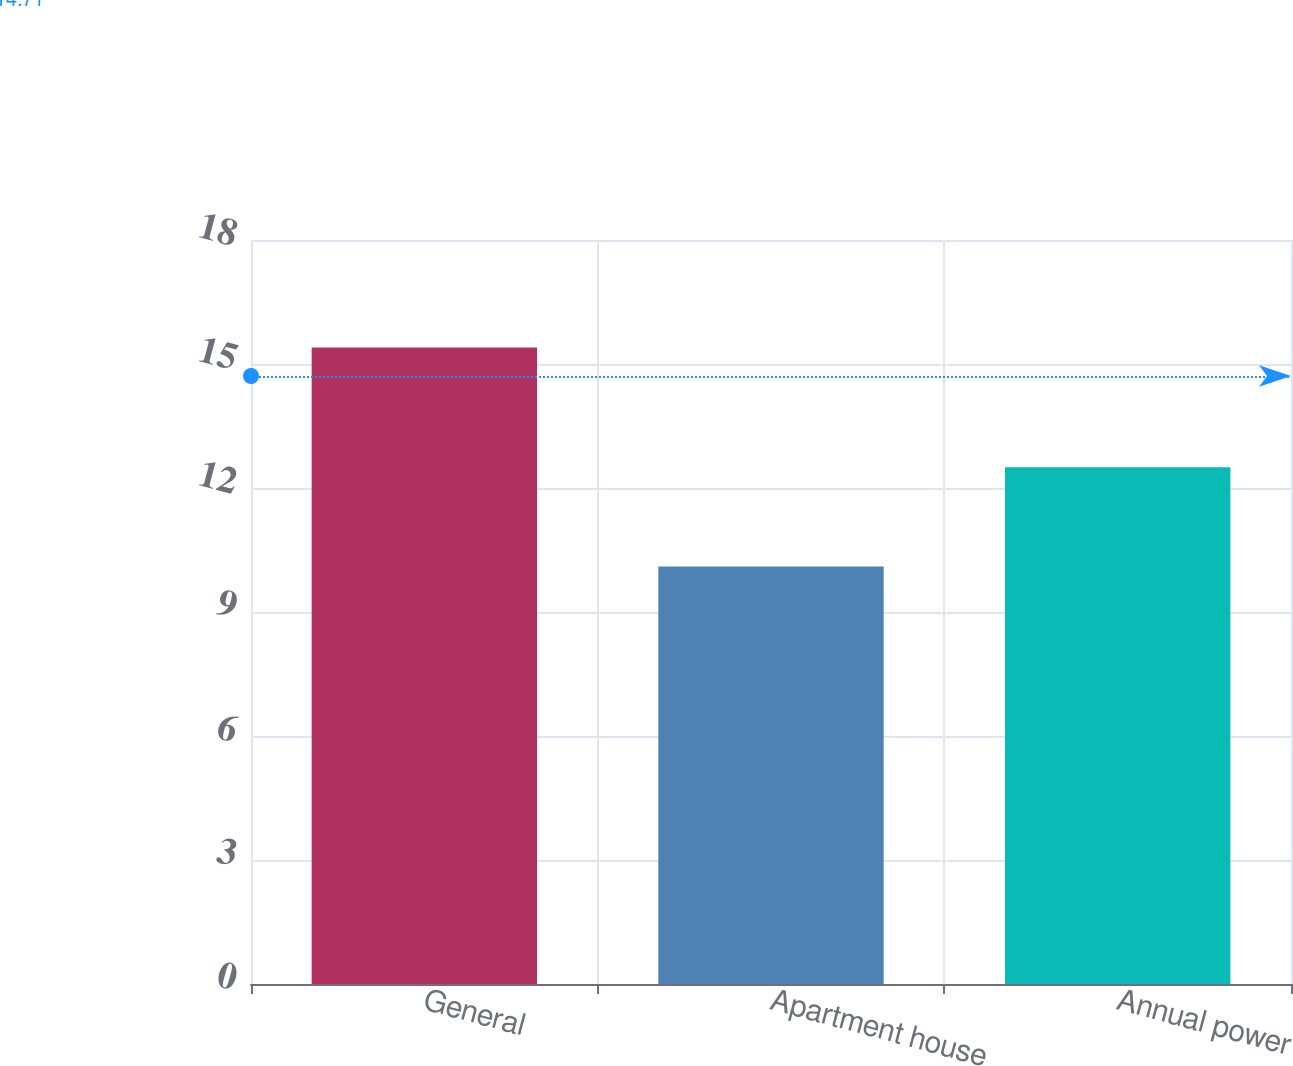Convert chart to OTSL. <chart><loc_0><loc_0><loc_500><loc_500><bar_chart><fcel>General<fcel>Apartment house<fcel>Annual power<nl><fcel>15.4<fcel>10.1<fcel>12.5<nl></chart> 